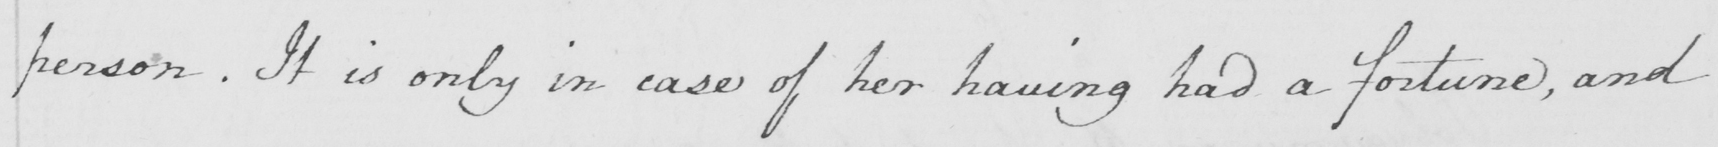What is written in this line of handwriting? person . It is only in case of her having had a fortune , and 